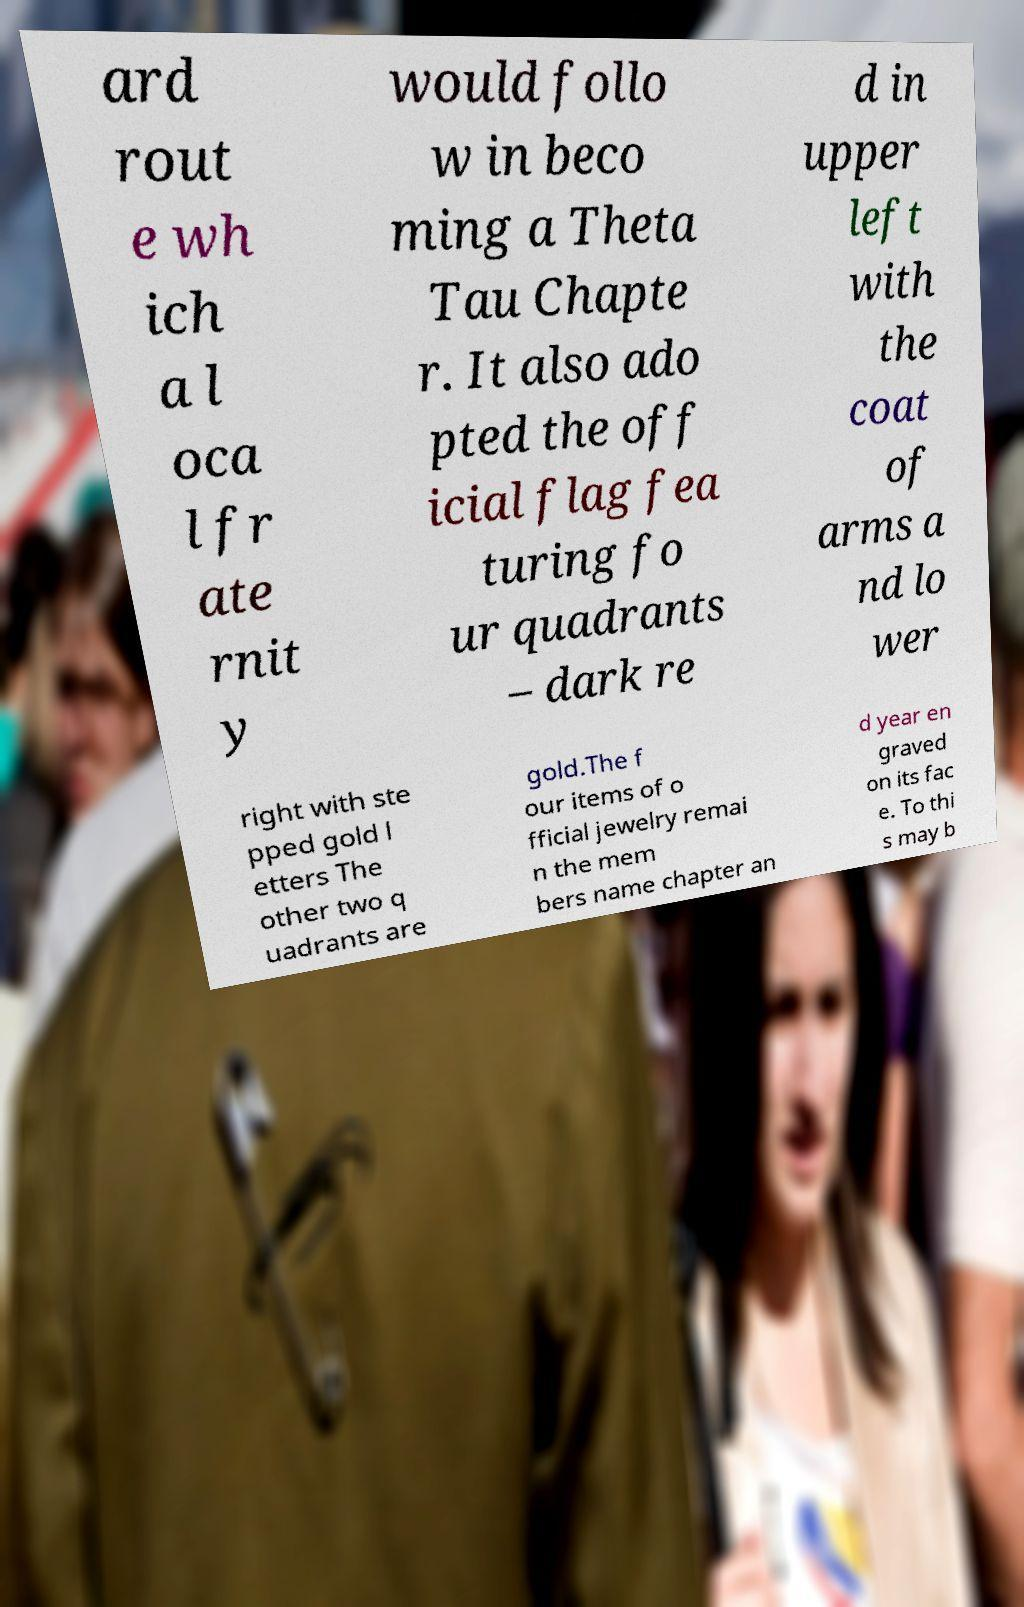Could you assist in decoding the text presented in this image and type it out clearly? ard rout e wh ich a l oca l fr ate rnit y would follo w in beco ming a Theta Tau Chapte r. It also ado pted the off icial flag fea turing fo ur quadrants – dark re d in upper left with the coat of arms a nd lo wer right with ste pped gold l etters The other two q uadrants are gold.The f our items of o fficial jewelry remai n the mem bers name chapter an d year en graved on its fac e. To thi s may b 